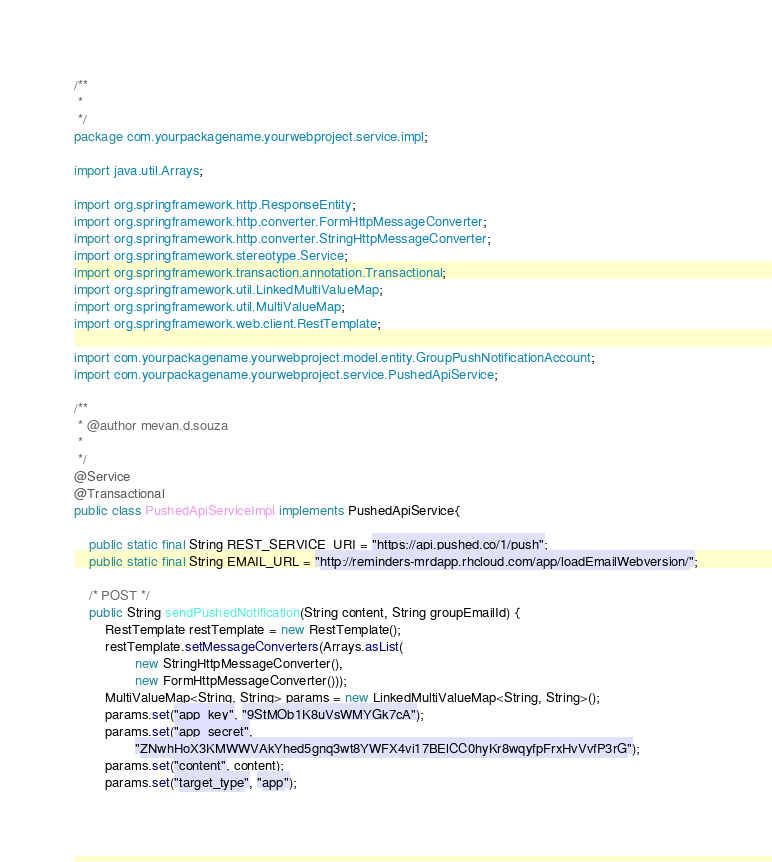<code> <loc_0><loc_0><loc_500><loc_500><_Java_>/**
 * 
 */
package com.yourpackagename.yourwebproject.service.impl;

import java.util.Arrays;

import org.springframework.http.ResponseEntity;
import org.springframework.http.converter.FormHttpMessageConverter;
import org.springframework.http.converter.StringHttpMessageConverter;
import org.springframework.stereotype.Service;
import org.springframework.transaction.annotation.Transactional;
import org.springframework.util.LinkedMultiValueMap;
import org.springframework.util.MultiValueMap;
import org.springframework.web.client.RestTemplate;

import com.yourpackagename.yourwebproject.model.entity.GroupPushNotificationAccount;
import com.yourpackagename.yourwebproject.service.PushedApiService;

/**
 * @author mevan.d.souza
 *
 */
@Service
@Transactional
public class PushedApiServiceImpl implements PushedApiService{

	public static final String REST_SERVICE_URI = "https://api.pushed.co/1/push";
	public static final String EMAIL_URL = "http://reminders-mrdapp.rhcloud.com/app/loadEmailWebversion/";

	/* POST */
	public String sendPushedNotification(String content, String groupEmailId) {
		RestTemplate restTemplate = new RestTemplate();
		restTemplate.setMessageConverters(Arrays.asList(
				new StringHttpMessageConverter(),
				new FormHttpMessageConverter()));
		MultiValueMap<String, String> params = new LinkedMultiValueMap<String, String>();
		params.set("app_key", "9StMOb1K8uVsWMYGk7cA");
		params.set("app_secret",
				"ZNwhHoX3KMWWVAkYhed5gnq3wt8YWFX4vi17BElCC0hyKr8wqyfpFrxHvVvfP3rG");
		params.set("content", content);
		params.set("target_type", "app");</code> 